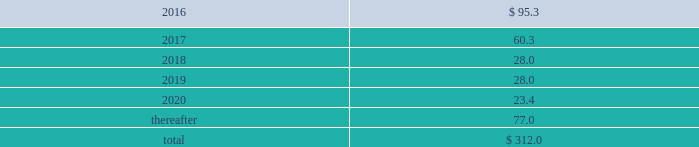Interest expense related to capital lease obligations was $ 1.6 million during the year ended december 31 , 2015 , and $ 1.6 million during both the years ended december 31 , 2014 and 2013 .
Purchase commitments in the table below , we set forth our enforceable and legally binding purchase obligations as of december 31 , 2015 .
Some of the amounts are based on management 2019s estimates and assumptions about these obligations , including their duration , the possibility of renewal , anticipated actions by third parties , and other factors .
Because these estimates and assumptions are necessarily subjective , our actual payments may vary from those reflected in the table .
Purchase orders made in the ordinary course of business are excluded below .
Any amounts for which we are liable under purchase orders are reflected on the consolidated balance sheets as accounts payable and accrued liabilities .
These obligations relate to various purchase agreements for items such as minimum amounts of fiber and energy purchases over periods ranging from one year to 20 years .
Total purchase commitments were as follows ( dollars in millions ) : .
The company purchased a total of $ 299.6 million , $ 265.9 million , and $ 61.7 million during the years ended december 31 , 2015 , 2014 , and 2013 , respectively , under these purchase agreements .
The increase in purchases the increase in purchases under these agreements in 2014 , compared with 2013 , relates to the acquisition of boise in fourth quarter 2013 .
Environmental liabilities the potential costs for various environmental matters are uncertain due to such factors as the unknown magnitude of possible cleanup costs , the complexity and evolving nature of governmental laws and regulations and their interpretations , and the timing , varying costs and effectiveness of alternative cleanup technologies .
From 2006 through 2015 , there were no significant environmental remediation costs at pca 2019s mills and corrugated plants .
At december 31 , 2015 , the company had $ 24.3 million of environmental-related reserves recorded on its consolidated balance sheet .
Of the $ 24.3 million , approximately $ 15.8 million related to environmental-related asset retirement obligations discussed in note 12 , asset retirement obligations , and $ 8.5 million related to our estimate of other environmental contingencies .
The company recorded $ 7.9 million in 201caccrued liabilities 201d and $ 16.4 million in 201cother long-term liabilities 201d on the consolidated balance sheet .
Liabilities recorded for environmental contingencies are estimates of the probable costs based upon available information and assumptions .
Because of these uncertainties , pca 2019s estimates may change .
The company believes that it is not reasonably possible that future environmental expenditures for remediation costs and asset retirement obligations above the $ 24.3 million accrued as of december 31 , 2015 , will have a material impact on its financial condition , results of operations , or cash flows .
Guarantees and indemnifications we provide guarantees , indemnifications , and other assurances to third parties in the normal course of our business .
These include tort indemnifications , environmental assurances , and representations and warranties in commercial agreements .
At december 31 , 2015 , we are not aware of any material liabilities arising from any guarantee , indemnification , or financial assurance we have provided .
If we determined such a liability was probable and subject to reasonable determination , we would accrue for it at that time. .
\\n\\n\\n\\nof the total purchase commitments , what percentage were due after 2020?\\n? 
Computations: (77.0 / 312.0)
Answer: 0.24679. 